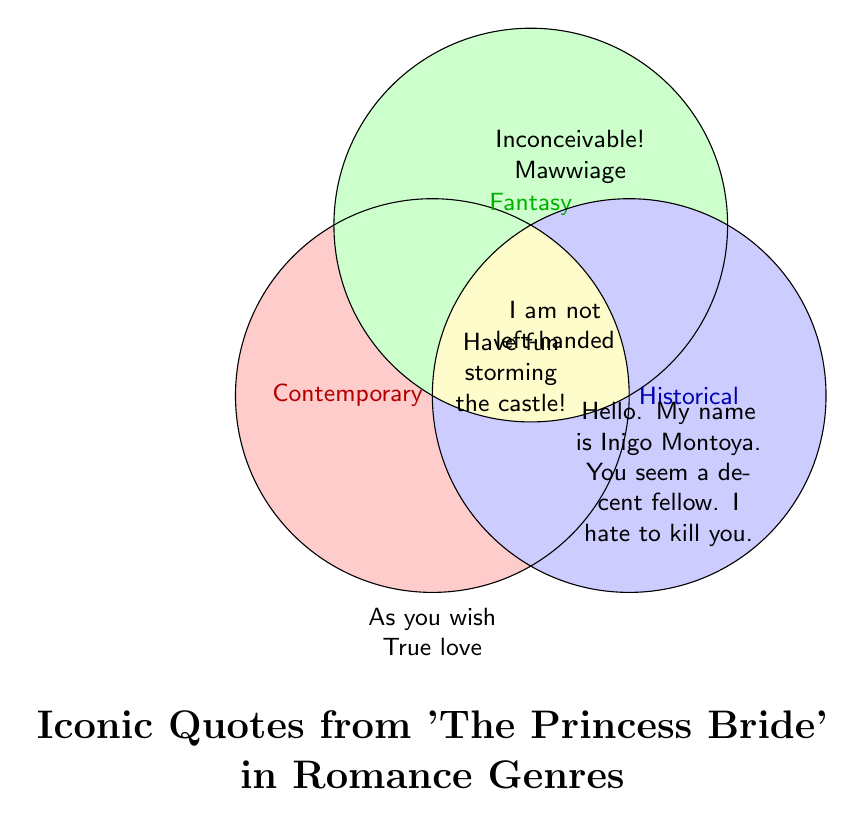What is the title of the Venn Diagram? The title is located at the bottom of the Venn Diagram and it is a short phrase summarizing the figure.
Answer: "Iconic Quotes from 'The Princess Bride' in Romance Genres" Which genre contains the quote "Hello. My name is Inigo Montoya"? The quote "Hello. My name is Inigo Montoya" is found in the section on the right labeled "Historical".
Answer: Historical Romance What colors represent the Contemporary, Fantasy, and Historical genres? Contemporary is represented by red, Fantasy by green, and Historical by blue.
Answer: Red, Green, Blue Which genres include the quote "Have fun storming the castle!"? The quote "Have fun storming the castle!" is placed in the overlapping section common to all three genres.
Answer: All three genres What is the quote shared between Contemporary and Fantasy genres only? The quote "I am not left-handed" appears in the overlapping region between Contemporary and Fantasy but not including Historical.
Answer: "I am not left-handed" How many quotes belong exclusively to the Contemporary Romance genre? There are two quotes listed directly under the Contemporary section without any overlap: "As you wish" and "True love".
Answer: 2 Is the quote "Mawwiage" found in the Historical genre? "Mawwiage" is placed in the Fantasy Romance section, and there is no overlap with the Historical genre.
Answer: No Which quote appears exclusively in the Historical Romance genre that involves a duel reference? The quote "You seem a decent fellow. I hate to kill you." appears in the Historical section and involves a duel reference.
Answer: "You seem a decent fellow. I hate to kill you." Are there more quotes in the Fantasy Romance genre than in the Historical Romance genre? The Fantasy Romance genre has two quotes: "Inconceivable!" and "Mawwiage". The Historical Romance genre also has two quotes: "Hello. My name is Inigo Montoya." and "You seem a decent fellow. I hate to kill you."
Answer: No Which quotes from the figure involve a direct or implied dialogue between characters? Analyzing the quotes, "Hello. My name is Inigo Montoya.", "You seem a decent fellow. I hate to kill you.", "I am not left-handed", and "Have fun storming the castle!" involve dialogues or implied conversations.
Answer: "Hello. My name is Inigo Montoya.", "You seem a decent fellow. I hate to kill you.", "I am not left-handed", "Have fun storming the castle!" 